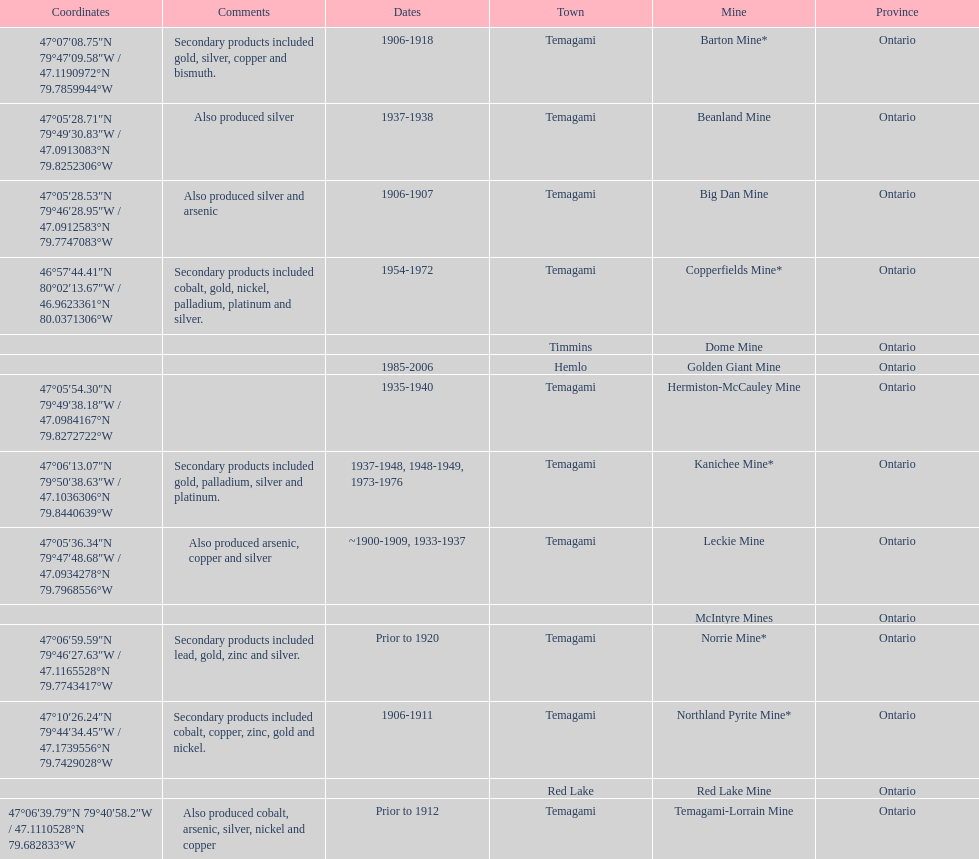Name a gold mine that was open at least 10 years. Barton Mine. 